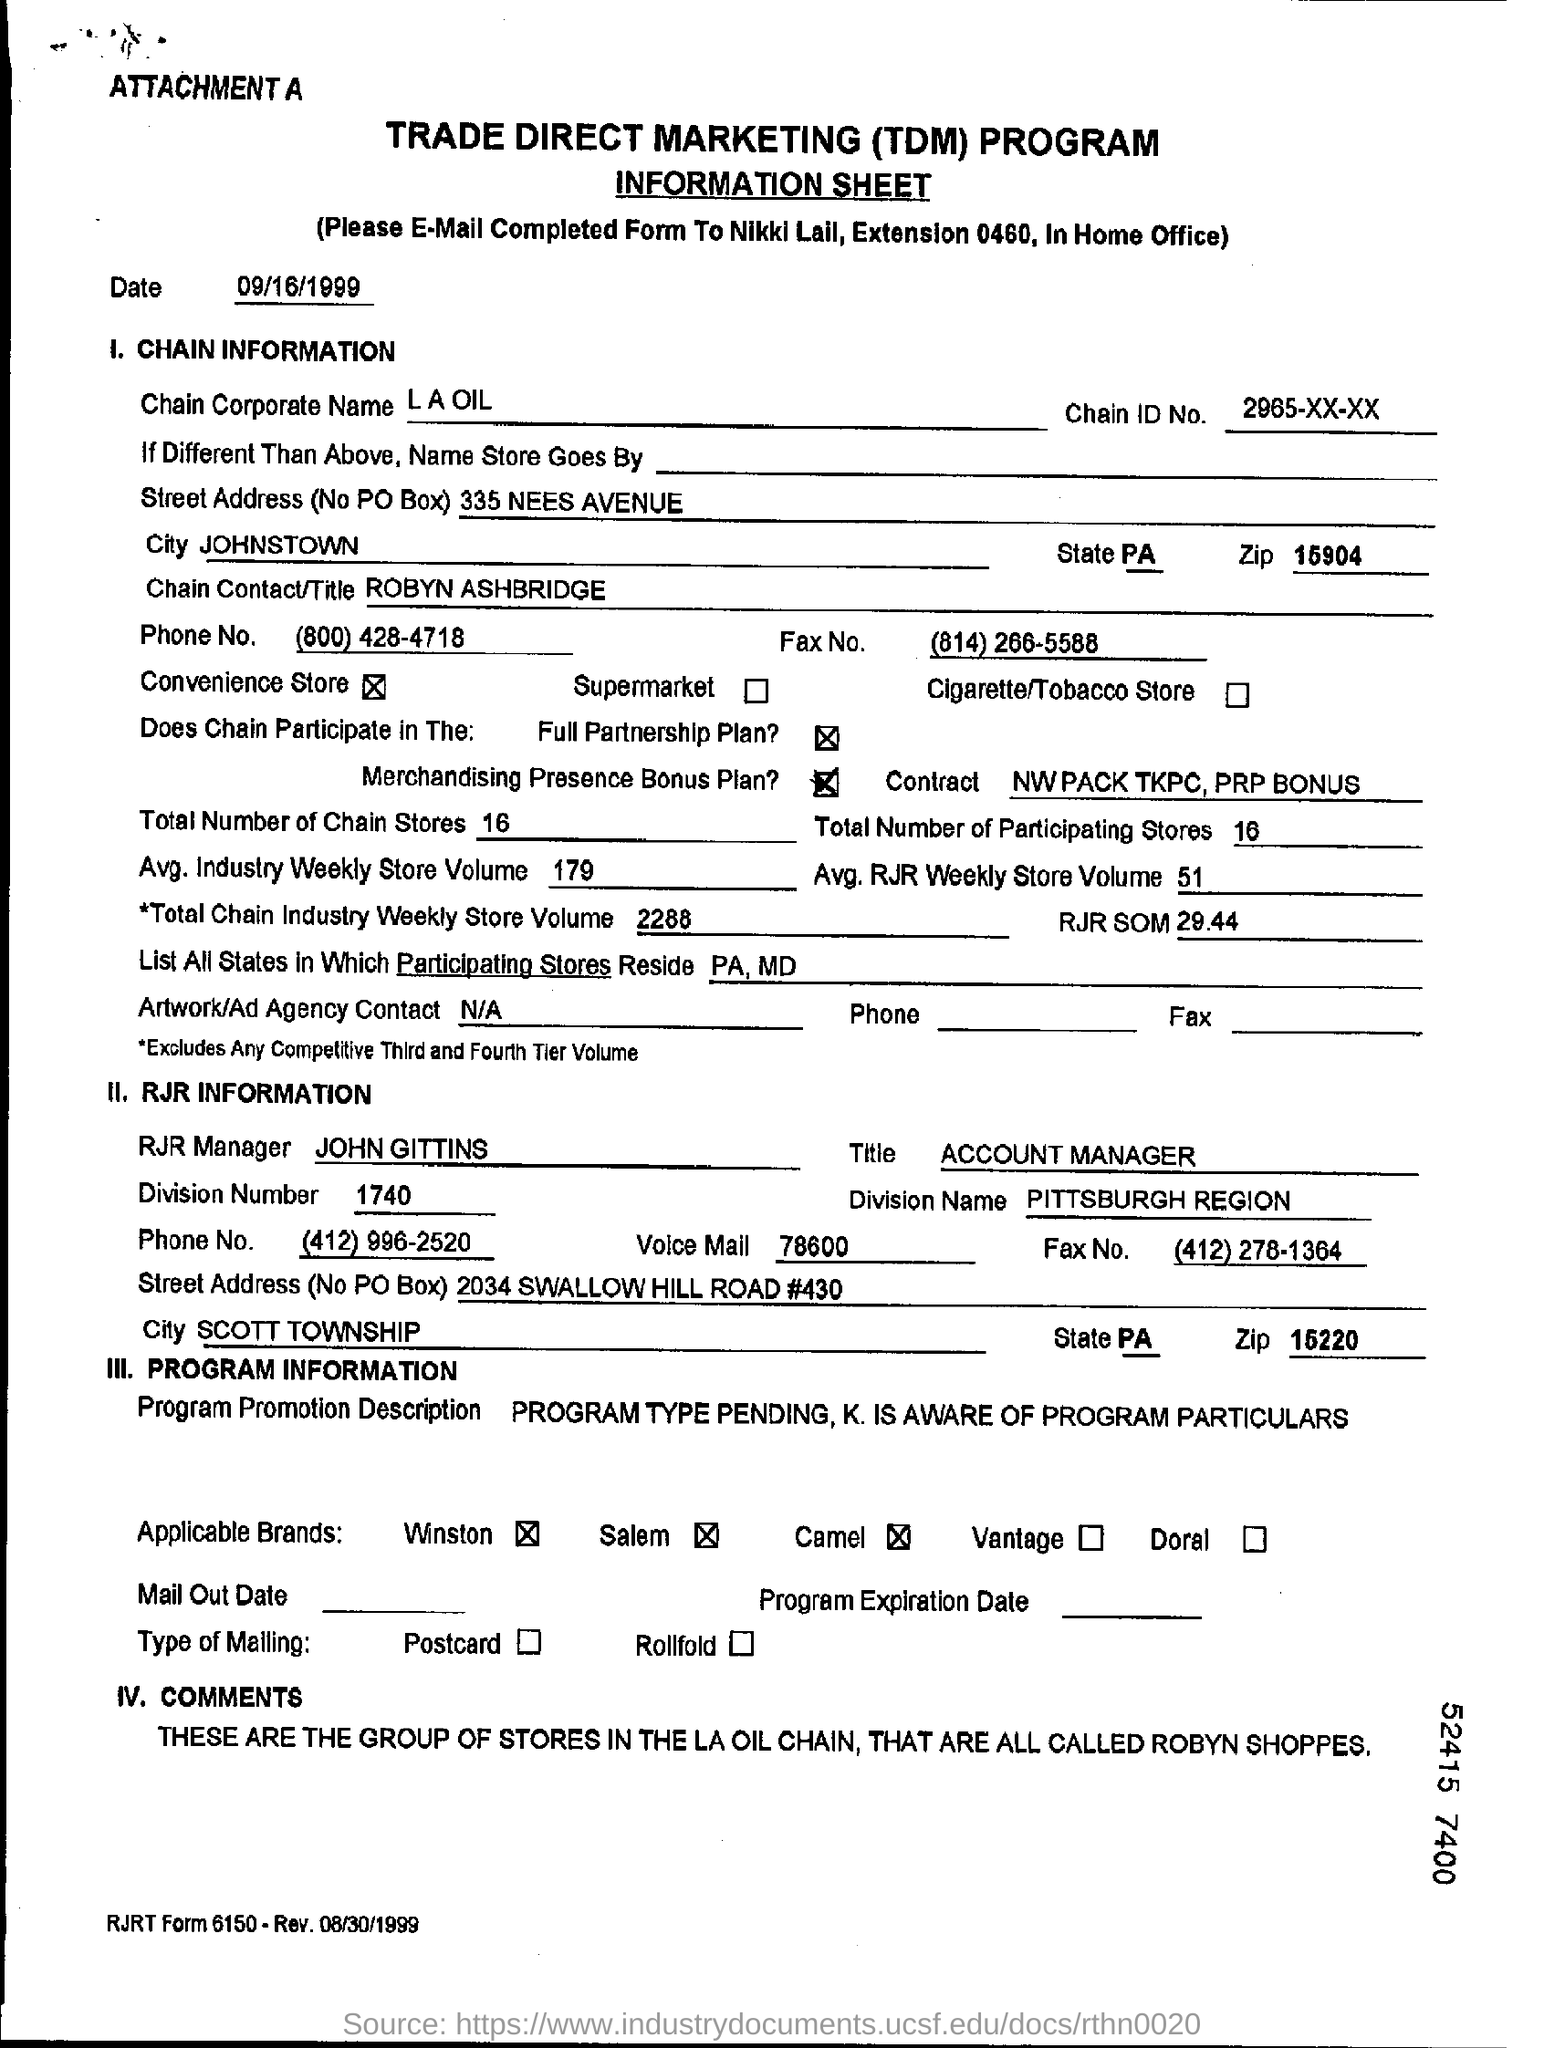Specify some key components in this picture. The name of the RJR manager is John Gittins. The chain corporate name is L.A. Oil. Chain ID No. 2965-xx-xx is a unique identifier assigned to a specific chain of events or actions. The chain contact/title is "ROBYN ASHBRIDGE. 